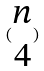Convert formula to latex. <formula><loc_0><loc_0><loc_500><loc_500>( \begin{matrix} n \\ 4 \end{matrix} )</formula> 